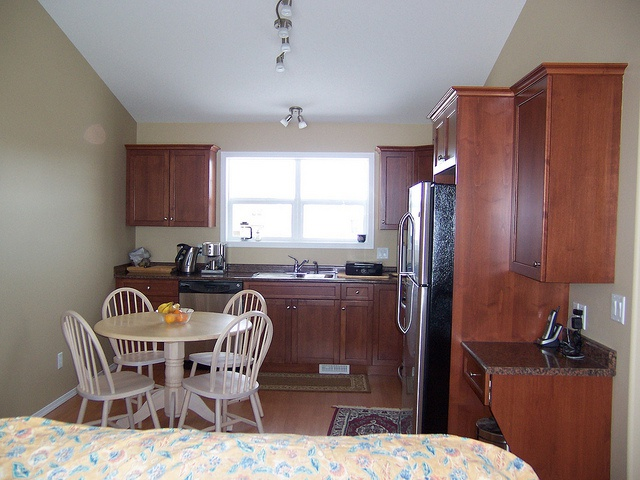Describe the objects in this image and their specific colors. I can see couch in gray, lightgray, tan, and lightblue tones, bed in gray, lightgray, tan, and lightblue tones, refrigerator in gray, black, white, and darkgray tones, chair in gray, darkgray, and maroon tones, and dining table in gray and darkgray tones in this image. 